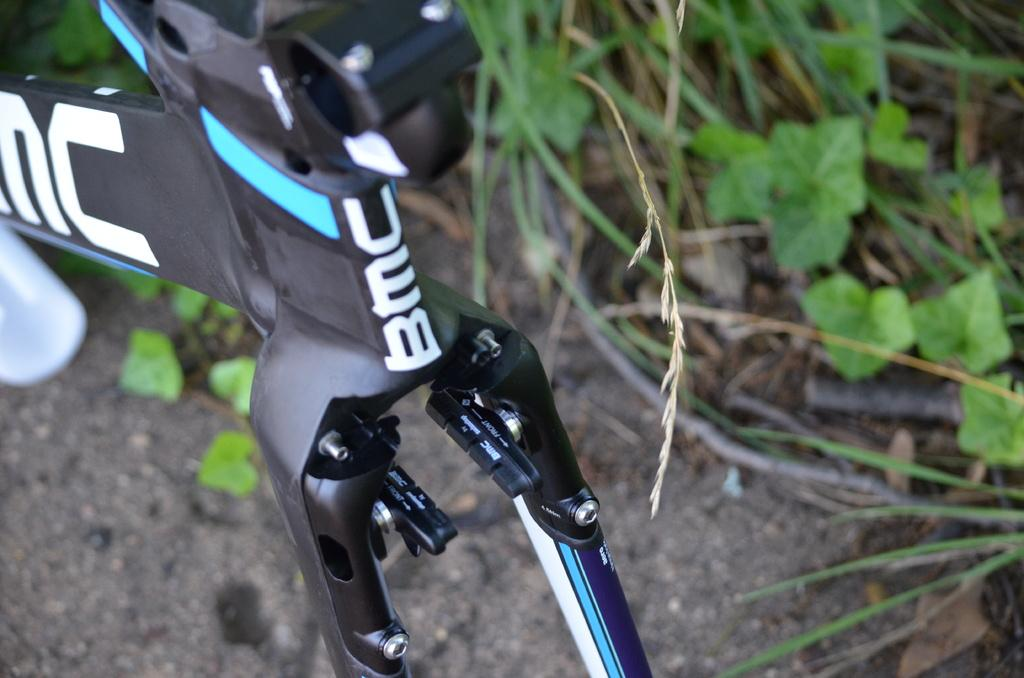What is located at the bottom of the image? There is a road at the bottom of the image. What can be seen at the top of the image? There are plants at the top of the image. What mode of transportation is present in the image? There is a bicycle in the image. Where is the map located in the image? There is no map present in the image. What type of vegetable can be seen growing among the plants in the image? There is no vegetable visible in the image; only plants are mentioned. 